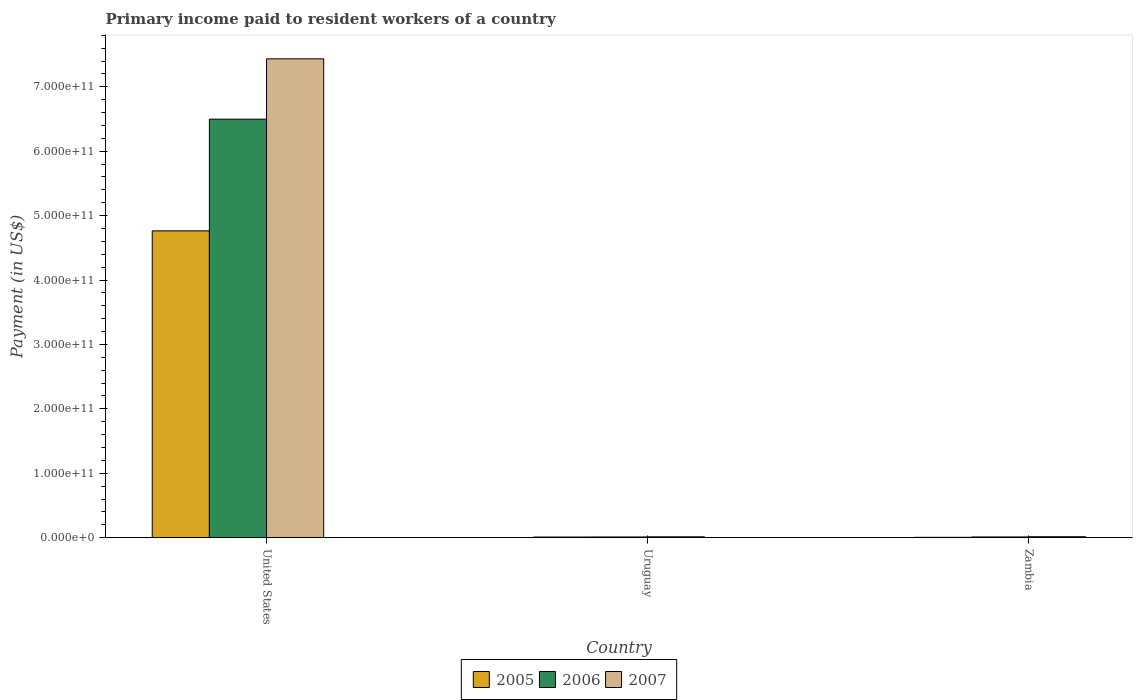Are the number of bars per tick equal to the number of legend labels?
Provide a short and direct response. Yes. How many bars are there on the 2nd tick from the right?
Ensure brevity in your answer.  3. What is the label of the 1st group of bars from the left?
Offer a terse response. United States. In how many cases, is the number of bars for a given country not equal to the number of legend labels?
Keep it short and to the point. 0. What is the amount paid to workers in 2006 in United States?
Your answer should be very brief. 6.50e+11. Across all countries, what is the maximum amount paid to workers in 2005?
Give a very brief answer. 4.76e+11. Across all countries, what is the minimum amount paid to workers in 2006?
Provide a succinct answer. 1.17e+09. In which country was the amount paid to workers in 2006 minimum?
Your answer should be very brief. Uruguay. What is the total amount paid to workers in 2006 in the graph?
Your response must be concise. 6.52e+11. What is the difference between the amount paid to workers in 2005 in United States and that in Uruguay?
Offer a very short reply. 4.75e+11. What is the difference between the amount paid to workers in 2007 in Uruguay and the amount paid to workers in 2006 in United States?
Ensure brevity in your answer.  -6.48e+11. What is the average amount paid to workers in 2007 per country?
Your answer should be very brief. 2.49e+11. What is the difference between the amount paid to workers of/in 2005 and amount paid to workers of/in 2006 in Uruguay?
Offer a very short reply. -1.13e+08. What is the ratio of the amount paid to workers in 2006 in Uruguay to that in Zambia?
Give a very brief answer. 0.99. What is the difference between the highest and the second highest amount paid to workers in 2007?
Your answer should be compact. 7.42e+11. What is the difference between the highest and the lowest amount paid to workers in 2007?
Give a very brief answer. 7.42e+11. Is the sum of the amount paid to workers in 2007 in United States and Uruguay greater than the maximum amount paid to workers in 2005 across all countries?
Provide a succinct answer. Yes. What does the 3rd bar from the left in United States represents?
Ensure brevity in your answer.  2007. What does the 1st bar from the right in Uruguay represents?
Provide a succinct answer. 2007. Is it the case that in every country, the sum of the amount paid to workers in 2006 and amount paid to workers in 2007 is greater than the amount paid to workers in 2005?
Make the answer very short. Yes. What is the difference between two consecutive major ticks on the Y-axis?
Make the answer very short. 1.00e+11. Are the values on the major ticks of Y-axis written in scientific E-notation?
Keep it short and to the point. Yes. Does the graph contain any zero values?
Ensure brevity in your answer.  No. How are the legend labels stacked?
Give a very brief answer. Horizontal. What is the title of the graph?
Give a very brief answer. Primary income paid to resident workers of a country. Does "2011" appear as one of the legend labels in the graph?
Ensure brevity in your answer.  No. What is the label or title of the Y-axis?
Your answer should be very brief. Payment (in US$). What is the Payment (in US$) in 2005 in United States?
Make the answer very short. 4.76e+11. What is the Payment (in US$) in 2006 in United States?
Offer a very short reply. 6.50e+11. What is the Payment (in US$) in 2007 in United States?
Your answer should be compact. 7.43e+11. What is the Payment (in US$) in 2005 in Uruguay?
Your answer should be very brief. 1.06e+09. What is the Payment (in US$) of 2006 in Uruguay?
Your answer should be very brief. 1.17e+09. What is the Payment (in US$) of 2007 in Uruguay?
Ensure brevity in your answer.  1.40e+09. What is the Payment (in US$) of 2005 in Zambia?
Your answer should be compact. 6.08e+08. What is the Payment (in US$) in 2006 in Zambia?
Make the answer very short. 1.19e+09. What is the Payment (in US$) in 2007 in Zambia?
Ensure brevity in your answer.  1.52e+09. Across all countries, what is the maximum Payment (in US$) of 2005?
Your answer should be very brief. 4.76e+11. Across all countries, what is the maximum Payment (in US$) of 2006?
Provide a short and direct response. 6.50e+11. Across all countries, what is the maximum Payment (in US$) in 2007?
Your response must be concise. 7.43e+11. Across all countries, what is the minimum Payment (in US$) of 2005?
Your response must be concise. 6.08e+08. Across all countries, what is the minimum Payment (in US$) in 2006?
Offer a very short reply. 1.17e+09. Across all countries, what is the minimum Payment (in US$) in 2007?
Your answer should be compact. 1.40e+09. What is the total Payment (in US$) in 2005 in the graph?
Offer a terse response. 4.78e+11. What is the total Payment (in US$) in 2006 in the graph?
Make the answer very short. 6.52e+11. What is the total Payment (in US$) in 2007 in the graph?
Offer a terse response. 7.46e+11. What is the difference between the Payment (in US$) of 2005 in United States and that in Uruguay?
Offer a very short reply. 4.75e+11. What is the difference between the Payment (in US$) in 2006 in United States and that in Uruguay?
Provide a succinct answer. 6.49e+11. What is the difference between the Payment (in US$) in 2007 in United States and that in Uruguay?
Ensure brevity in your answer.  7.42e+11. What is the difference between the Payment (in US$) of 2005 in United States and that in Zambia?
Your answer should be very brief. 4.76e+11. What is the difference between the Payment (in US$) in 2006 in United States and that in Zambia?
Keep it short and to the point. 6.49e+11. What is the difference between the Payment (in US$) in 2007 in United States and that in Zambia?
Your answer should be very brief. 7.42e+11. What is the difference between the Payment (in US$) in 2005 in Uruguay and that in Zambia?
Make the answer very short. 4.50e+08. What is the difference between the Payment (in US$) in 2006 in Uruguay and that in Zambia?
Offer a terse response. -1.68e+07. What is the difference between the Payment (in US$) of 2007 in Uruguay and that in Zambia?
Offer a very short reply. -1.20e+08. What is the difference between the Payment (in US$) in 2005 in United States and the Payment (in US$) in 2006 in Uruguay?
Provide a succinct answer. 4.75e+11. What is the difference between the Payment (in US$) of 2005 in United States and the Payment (in US$) of 2007 in Uruguay?
Offer a very short reply. 4.75e+11. What is the difference between the Payment (in US$) of 2006 in United States and the Payment (in US$) of 2007 in Uruguay?
Provide a succinct answer. 6.48e+11. What is the difference between the Payment (in US$) in 2005 in United States and the Payment (in US$) in 2006 in Zambia?
Give a very brief answer. 4.75e+11. What is the difference between the Payment (in US$) in 2005 in United States and the Payment (in US$) in 2007 in Zambia?
Offer a very short reply. 4.75e+11. What is the difference between the Payment (in US$) in 2006 in United States and the Payment (in US$) in 2007 in Zambia?
Make the answer very short. 6.48e+11. What is the difference between the Payment (in US$) of 2005 in Uruguay and the Payment (in US$) of 2006 in Zambia?
Give a very brief answer. -1.29e+08. What is the difference between the Payment (in US$) of 2005 in Uruguay and the Payment (in US$) of 2007 in Zambia?
Provide a succinct answer. -4.64e+08. What is the difference between the Payment (in US$) of 2006 in Uruguay and the Payment (in US$) of 2007 in Zambia?
Provide a short and direct response. -3.52e+08. What is the average Payment (in US$) of 2005 per country?
Make the answer very short. 1.59e+11. What is the average Payment (in US$) of 2006 per country?
Provide a succinct answer. 2.17e+11. What is the average Payment (in US$) of 2007 per country?
Give a very brief answer. 2.49e+11. What is the difference between the Payment (in US$) of 2005 and Payment (in US$) of 2006 in United States?
Offer a very short reply. -1.73e+11. What is the difference between the Payment (in US$) of 2005 and Payment (in US$) of 2007 in United States?
Make the answer very short. -2.67e+11. What is the difference between the Payment (in US$) in 2006 and Payment (in US$) in 2007 in United States?
Offer a very short reply. -9.37e+1. What is the difference between the Payment (in US$) in 2005 and Payment (in US$) in 2006 in Uruguay?
Provide a succinct answer. -1.13e+08. What is the difference between the Payment (in US$) in 2005 and Payment (in US$) in 2007 in Uruguay?
Your response must be concise. -3.44e+08. What is the difference between the Payment (in US$) of 2006 and Payment (in US$) of 2007 in Uruguay?
Your answer should be compact. -2.31e+08. What is the difference between the Payment (in US$) of 2005 and Payment (in US$) of 2006 in Zambia?
Ensure brevity in your answer.  -5.79e+08. What is the difference between the Payment (in US$) of 2005 and Payment (in US$) of 2007 in Zambia?
Offer a very short reply. -9.14e+08. What is the difference between the Payment (in US$) in 2006 and Payment (in US$) in 2007 in Zambia?
Give a very brief answer. -3.35e+08. What is the ratio of the Payment (in US$) in 2005 in United States to that in Uruguay?
Ensure brevity in your answer.  450.54. What is the ratio of the Payment (in US$) of 2006 in United States to that in Uruguay?
Offer a very short reply. 555.42. What is the ratio of the Payment (in US$) of 2007 in United States to that in Uruguay?
Offer a terse response. 530.67. What is the ratio of the Payment (in US$) of 2005 in United States to that in Zambia?
Ensure brevity in your answer.  783.84. What is the ratio of the Payment (in US$) of 2006 in United States to that in Zambia?
Provide a short and direct response. 547.53. What is the ratio of the Payment (in US$) in 2007 in United States to that in Zambia?
Your response must be concise. 488.66. What is the ratio of the Payment (in US$) in 2005 in Uruguay to that in Zambia?
Give a very brief answer. 1.74. What is the ratio of the Payment (in US$) of 2006 in Uruguay to that in Zambia?
Your response must be concise. 0.99. What is the ratio of the Payment (in US$) in 2007 in Uruguay to that in Zambia?
Provide a short and direct response. 0.92. What is the difference between the highest and the second highest Payment (in US$) of 2005?
Offer a very short reply. 4.75e+11. What is the difference between the highest and the second highest Payment (in US$) of 2006?
Your response must be concise. 6.49e+11. What is the difference between the highest and the second highest Payment (in US$) in 2007?
Your answer should be compact. 7.42e+11. What is the difference between the highest and the lowest Payment (in US$) of 2005?
Your answer should be very brief. 4.76e+11. What is the difference between the highest and the lowest Payment (in US$) in 2006?
Give a very brief answer. 6.49e+11. What is the difference between the highest and the lowest Payment (in US$) of 2007?
Keep it short and to the point. 7.42e+11. 